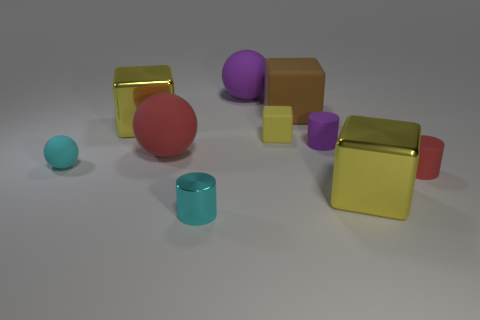Compare the number of spherical objects to the cubic ones in the image. In the image, there are two spherical objects and four objects with cubic or cuboid shapes, indicating a greater quantity of the latter category. 